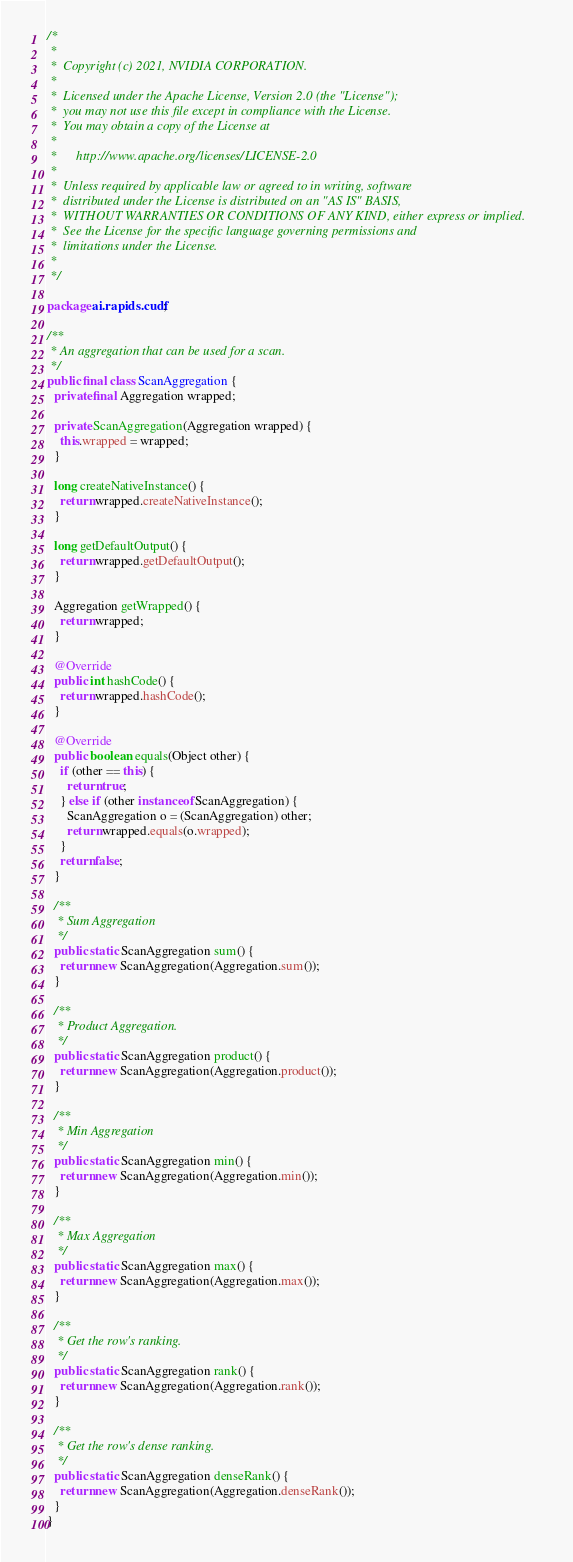Convert code to text. <code><loc_0><loc_0><loc_500><loc_500><_Java_>/*
 *
 *  Copyright (c) 2021, NVIDIA CORPORATION.
 *
 *  Licensed under the Apache License, Version 2.0 (the "License");
 *  you may not use this file except in compliance with the License.
 *  You may obtain a copy of the License at
 *
 *      http://www.apache.org/licenses/LICENSE-2.0
 *
 *  Unless required by applicable law or agreed to in writing, software
 *  distributed under the License is distributed on an "AS IS" BASIS,
 *  WITHOUT WARRANTIES OR CONDITIONS OF ANY KIND, either express or implied.
 *  See the License for the specific language governing permissions and
 *  limitations under the License.
 *
 */

package ai.rapids.cudf;

/**
 * An aggregation that can be used for a scan.
 */
public final class ScanAggregation {
  private final Aggregation wrapped;

  private ScanAggregation(Aggregation wrapped) {
    this.wrapped = wrapped;
  }

  long createNativeInstance() {
    return wrapped.createNativeInstance();
  }

  long getDefaultOutput() {
    return wrapped.getDefaultOutput();
  }

  Aggregation getWrapped() {
    return wrapped;
  }

  @Override
  public int hashCode() {
    return wrapped.hashCode();
  }

  @Override
  public boolean equals(Object other) {
    if (other == this) {
      return true;
    } else if (other instanceof ScanAggregation) {
      ScanAggregation o = (ScanAggregation) other;
      return wrapped.equals(o.wrapped);
    }
    return false;
  }

  /**
   * Sum Aggregation
   */
  public static ScanAggregation sum() {
    return new ScanAggregation(Aggregation.sum());
  }

  /**
   * Product Aggregation.
   */
  public static ScanAggregation product() {
    return new ScanAggregation(Aggregation.product());
  }

  /**
   * Min Aggregation
   */
  public static ScanAggregation min() {
    return new ScanAggregation(Aggregation.min());
  }

  /**
   * Max Aggregation
   */
  public static ScanAggregation max() {
    return new ScanAggregation(Aggregation.max());
  }

  /**
   * Get the row's ranking.
   */
  public static ScanAggregation rank() {
    return new ScanAggregation(Aggregation.rank());
  }

  /**
   * Get the row's dense ranking.
   */
  public static ScanAggregation denseRank() {
    return new ScanAggregation(Aggregation.denseRank());
  }
}
</code> 